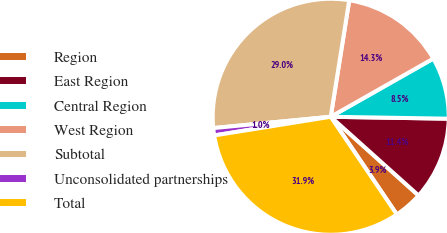<chart> <loc_0><loc_0><loc_500><loc_500><pie_chart><fcel>Region<fcel>East Region<fcel>Central Region<fcel>West Region<fcel>Subtotal<fcel>Unconsolidated partnerships<fcel>Total<nl><fcel>3.9%<fcel>11.37%<fcel>8.47%<fcel>14.28%<fcel>29.04%<fcel>1.0%<fcel>31.94%<nl></chart> 